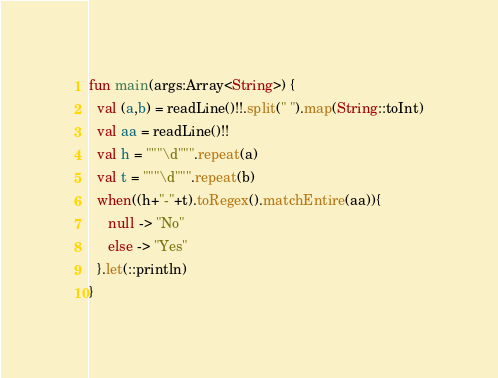Convert code to text. <code><loc_0><loc_0><loc_500><loc_500><_Kotlin_>fun main(args:Array<String>) {
  val (a,b) = readLine()!!.split(" ").map(String::toInt)
  val aa = readLine()!!
  val h = """\d""".repeat(a)
  val t = """\d""".repeat(b)
  when((h+"-"+t).toRegex().matchEntire(aa)){
     null -> "No"
     else -> "Yes"
  }.let(::println)
}</code> 